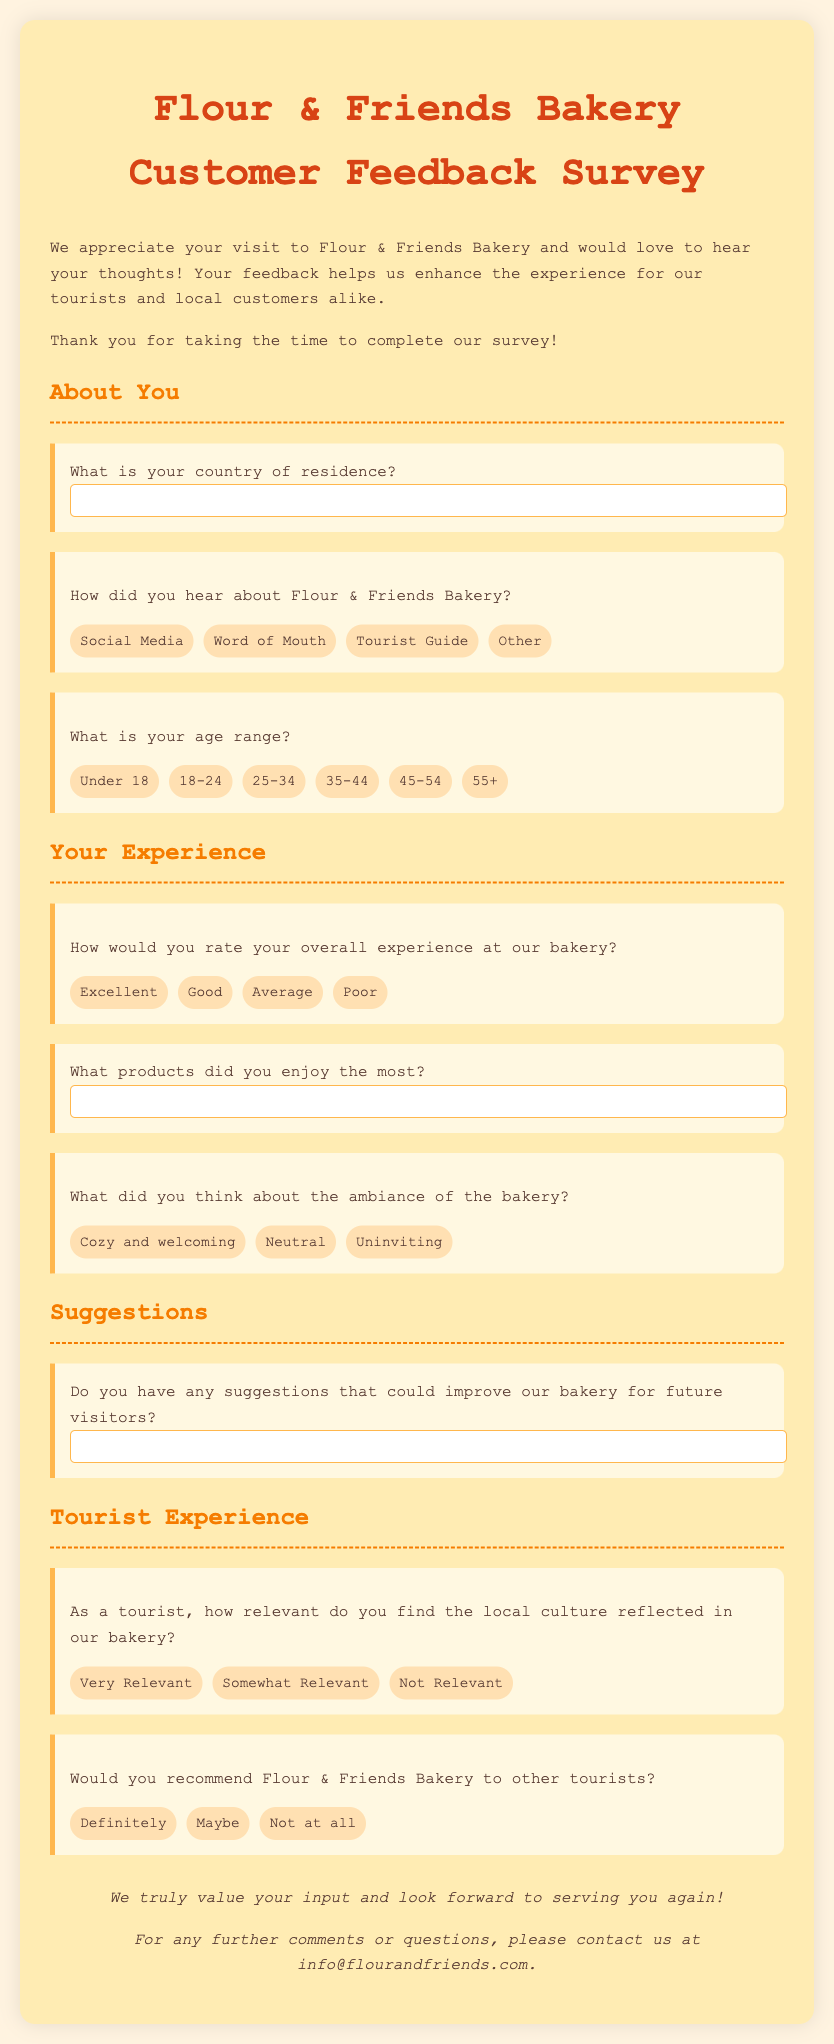What is the title of the survey? The title of the survey is mentioned at the top of the document as "Flour & Friends Bakery - Customer Feedback Survey."
Answer: Flour & Friends Bakery - Customer Feedback Survey What is the color of the text used in the document? The text in the document is colored in a specific shade, identified as #5D4037.
Answer: #5D4037 How many options are provided for the age range question? The age range question has multiple options listed to choose from, specifically six different age categories.
Answer: 6 What is the first question asked in the survey? The first question asks the participants about their country of residence, clearly stated in the introduction.
Answer: What is your country of residence? How many options are there for the overall experience rating? The overall experience rating question provides participants with four response options to choose from.
Answer: 4 What type of suggestions does the survey ask for? The survey asks for suggestions regarding improvements to the bakery specifically for future visitors.
Answer: Improvements As a tourist, what aspect does the bakery ask about its relevance? The bakery inquires specifically about how tourists find the local culture reflected in its offerings.
Answer: Local culture Would the survey provide any specific contact details? Yes, the survey provides contact details for further comments or questions at the end of the document.
Answer: info@flourandfriends.com What is the ambiance feedback option that indicates an inviting space? Among the feedback options for ambiance, one specifically reflects a warm and pleasant atmosphere.
Answer: Cozy and welcoming Would you find any questions about the bakery's recommendations? Yes, there is a question directly asking if participants would recommend the bakery to other tourists.
Answer: Recommend 